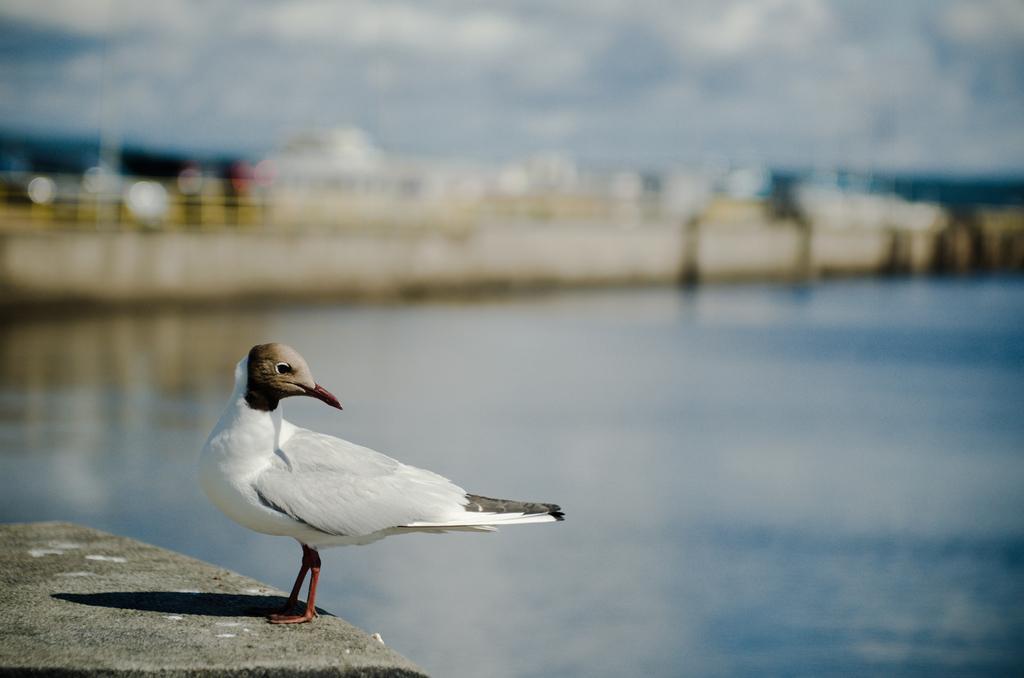Describe this image in one or two sentences. Background portion of the picture is blur. In this picture we can see the water. We can see a bird on the concrete surface. 